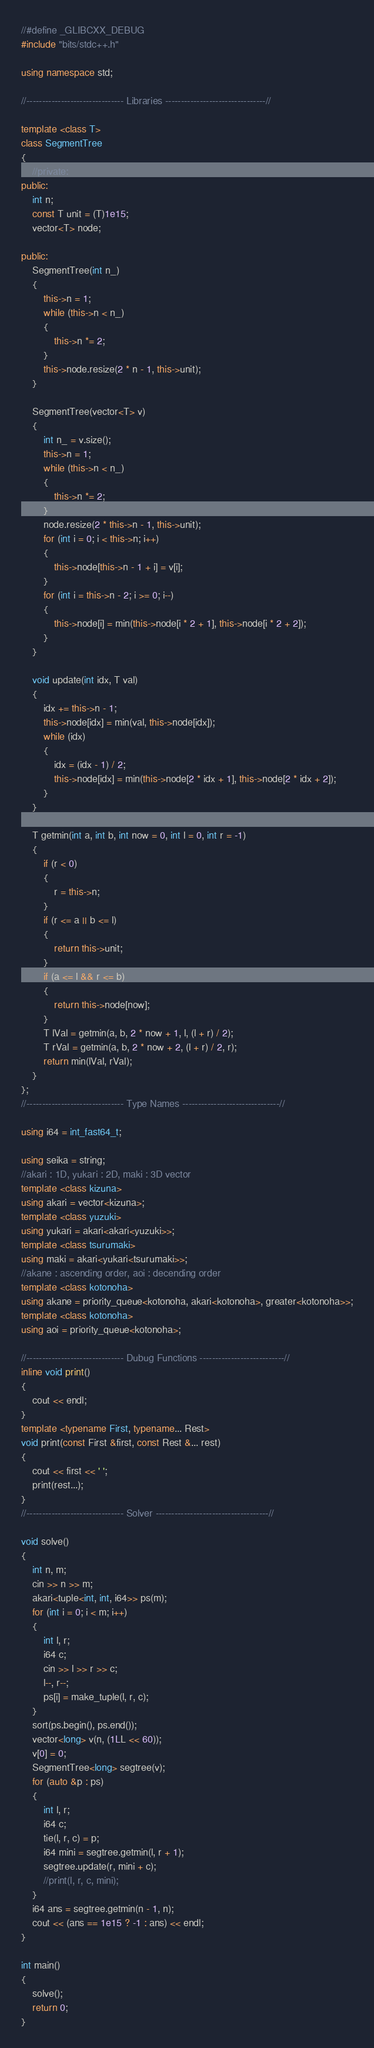<code> <loc_0><loc_0><loc_500><loc_500><_C++_>//#define _GLIBCXX_DEBUG
#include "bits/stdc++.h"

using namespace std;

//------------------------------- Libraries --------------------------------//

template <class T>
class SegmentTree
{
    //private:
public:
    int n;
    const T unit = (T)1e15;
    vector<T> node;

public:
    SegmentTree(int n_)
    {
        this->n = 1;
        while (this->n < n_)
        {
            this->n *= 2;
        }
        this->node.resize(2 * n - 1, this->unit);
    }

    SegmentTree(vector<T> v)
    {
        int n_ = v.size();
        this->n = 1;
        while (this->n < n_)
        {
            this->n *= 2;
        }
        node.resize(2 * this->n - 1, this->unit);
        for (int i = 0; i < this->n; i++)
        {
            this->node[this->n - 1 + i] = v[i];
        }
        for (int i = this->n - 2; i >= 0; i--)
        {
            this->node[i] = min(this->node[i * 2 + 1], this->node[i * 2 + 2]);
        }
    }

    void update(int idx, T val)
    {
        idx += this->n - 1;
        this->node[idx] = min(val, this->node[idx]);
        while (idx)
        {
            idx = (idx - 1) / 2;
            this->node[idx] = min(this->node[2 * idx + 1], this->node[2 * idx + 2]);
        }
    }

    T getmin(int a, int b, int now = 0, int l = 0, int r = -1)
    {
        if (r < 0)
        {
            r = this->n;
        }
        if (r <= a || b <= l)
        {
            return this->unit;
        }
        if (a <= l && r <= b)
        {
            return this->node[now];
        }
        T lVal = getmin(a, b, 2 * now + 1, l, (l + r) / 2);
        T rVal = getmin(a, b, 2 * now + 2, (l + r) / 2, r);
        return min(lVal, rVal);
    }
};
//------------------------------- Type Names -------------------------------//

using i64 = int_fast64_t;

using seika = string;
//akari : 1D, yukari : 2D, maki : 3D vector
template <class kizuna>
using akari = vector<kizuna>;
template <class yuzuki>
using yukari = akari<akari<yuzuki>>;
template <class tsurumaki>
using maki = akari<yukari<tsurumaki>>;
//akane : ascending order, aoi : decending order
template <class kotonoha>
using akane = priority_queue<kotonoha, akari<kotonoha>, greater<kotonoha>>;
template <class kotonoha>
using aoi = priority_queue<kotonoha>;

//------------------------------- Dubug Functions ---------------------------//
inline void print()
{
    cout << endl;
}
template <typename First, typename... Rest>
void print(const First &first, const Rest &... rest)
{
    cout << first << ' ';
    print(rest...);
}
//------------------------------- Solver ------------------------------------//

void solve()
{
    int n, m;
    cin >> n >> m;
    akari<tuple<int, int, i64>> ps(m);
    for (int i = 0; i < m; i++)
    {
        int l, r;
        i64 c;
        cin >> l >> r >> c;
        l--, r--;
        ps[i] = make_tuple(l, r, c);
    }
    sort(ps.begin(), ps.end());
    vector<long> v(n, (1LL << 60));
    v[0] = 0;
    SegmentTree<long> segtree(v);
    for (auto &p : ps)
    {
        int l, r;
        i64 c;
        tie(l, r, c) = p;
        i64 mini = segtree.getmin(l, r + 1);
        segtree.update(r, mini + c);
        //print(l, r, c, mini);
    }
    i64 ans = segtree.getmin(n - 1, n);
    cout << (ans == 1e15 ? -1 : ans) << endl;
}

int main()
{
    solve();
    return 0;
}</code> 